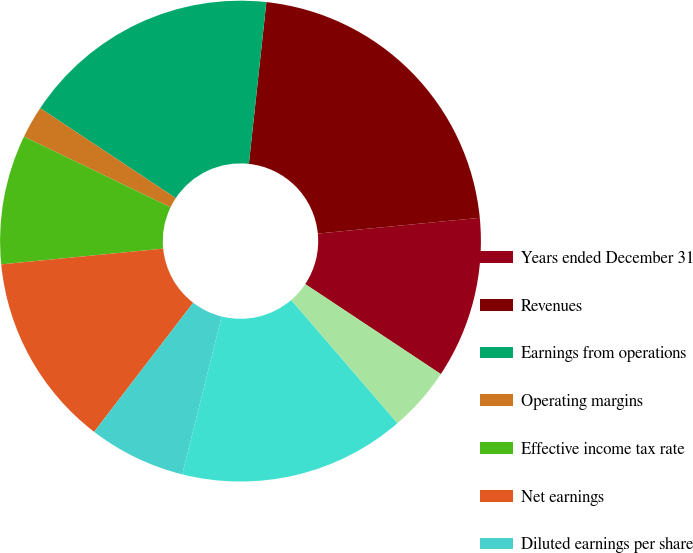Convert chart to OTSL. <chart><loc_0><loc_0><loc_500><loc_500><pie_chart><fcel>Years ended December 31<fcel>Revenues<fcel>Earnings from operations<fcel>Operating margins<fcel>Effective income tax rate<fcel>Net earnings<fcel>Diluted earnings per share<fcel>Core operating earnings<fcel>Core operating margins<fcel>Core earnings per share<nl><fcel>10.87%<fcel>21.74%<fcel>17.39%<fcel>2.17%<fcel>8.7%<fcel>13.04%<fcel>6.52%<fcel>15.22%<fcel>0.0%<fcel>4.35%<nl></chart> 